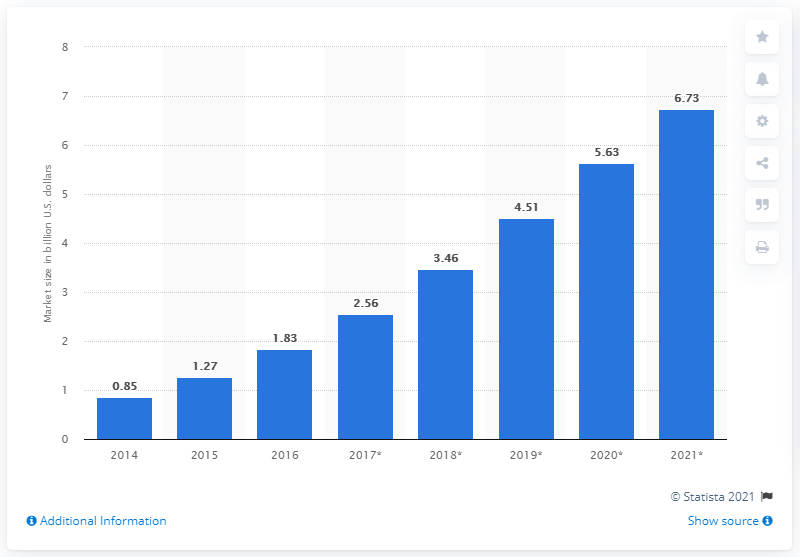Specify some key components in this picture. The estimated value of the OpenStack market in 2018 was 3.46 billion dollars. 